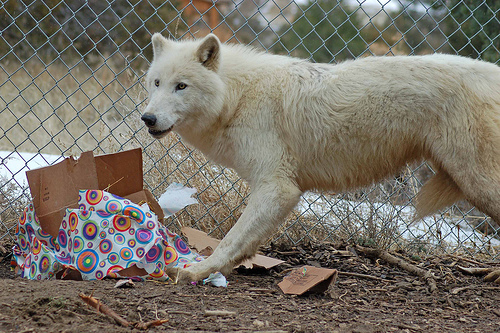<image>
Is the wolf on the trash? No. The wolf is not positioned on the trash. They may be near each other, but the wolf is not supported by or resting on top of the trash. Is the canid behind the box? No. The canid is not behind the box. From this viewpoint, the canid appears to be positioned elsewhere in the scene. Is there a dog behind the fence? No. The dog is not behind the fence. From this viewpoint, the dog appears to be positioned elsewhere in the scene. 